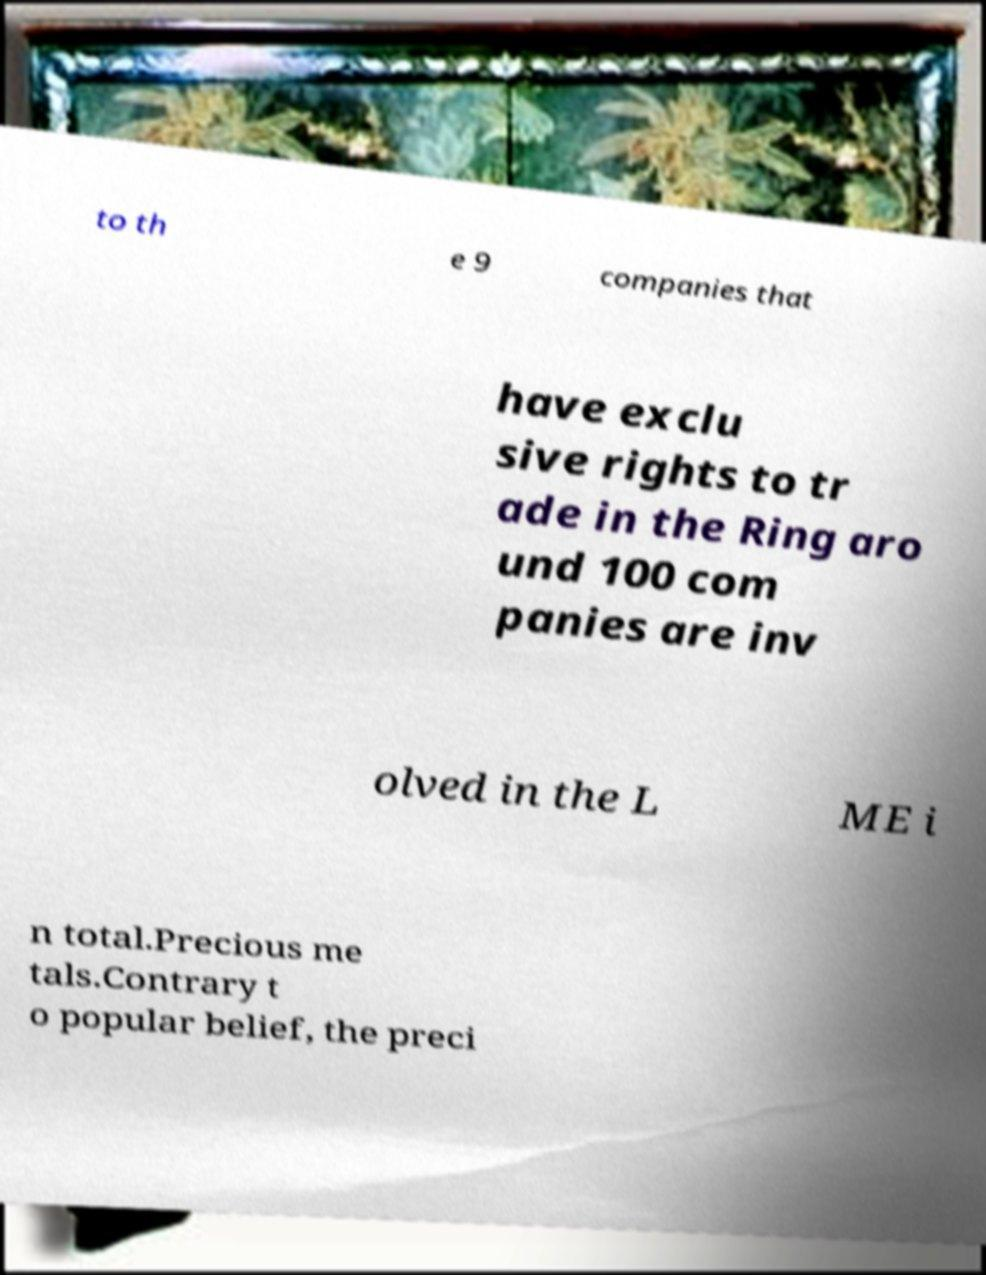Please identify and transcribe the text found in this image. to th e 9 companies that have exclu sive rights to tr ade in the Ring aro und 100 com panies are inv olved in the L ME i n total.Precious me tals.Contrary t o popular belief, the preci 